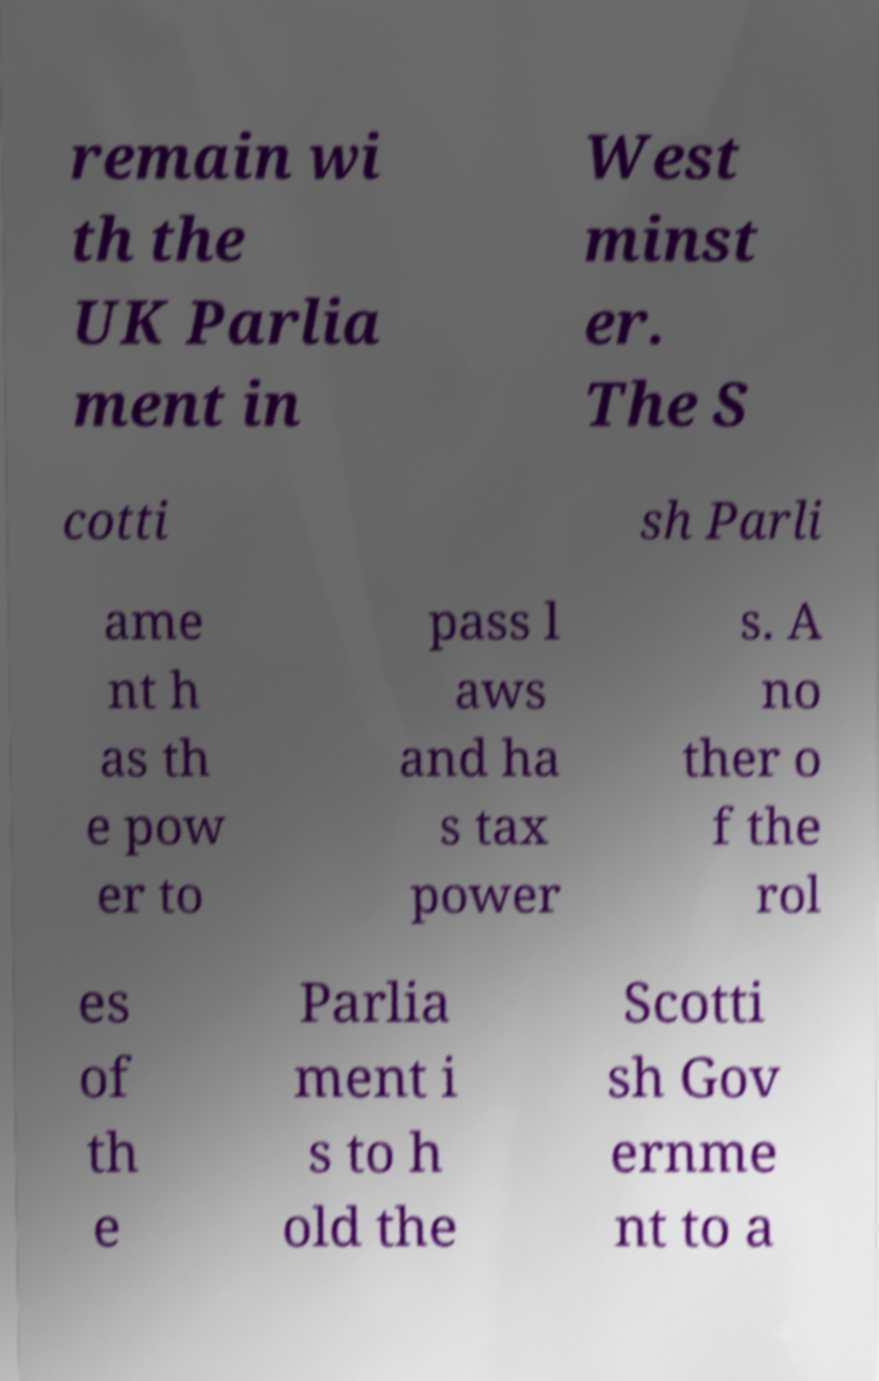Can you accurately transcribe the text from the provided image for me? remain wi th the UK Parlia ment in West minst er. The S cotti sh Parli ame nt h as th e pow er to pass l aws and ha s tax power s. A no ther o f the rol es of th e Parlia ment i s to h old the Scotti sh Gov ernme nt to a 